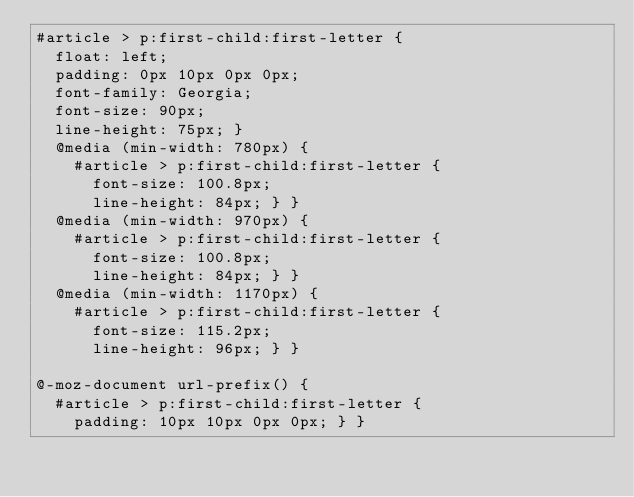Convert code to text. <code><loc_0><loc_0><loc_500><loc_500><_CSS_>#article > p:first-child:first-letter {
  float: left;
  padding: 0px 10px 0px 0px;
  font-family: Georgia;
  font-size: 90px;
  line-height: 75px; }
  @media (min-width: 780px) {
    #article > p:first-child:first-letter {
      font-size: 100.8px;
      line-height: 84px; } }
  @media (min-width: 970px) {
    #article > p:first-child:first-letter {
      font-size: 100.8px;
      line-height: 84px; } }
  @media (min-width: 1170px) {
    #article > p:first-child:first-letter {
      font-size: 115.2px;
      line-height: 96px; } }

@-moz-document url-prefix() {
  #article > p:first-child:first-letter {
    padding: 10px 10px 0px 0px; } }
</code> 